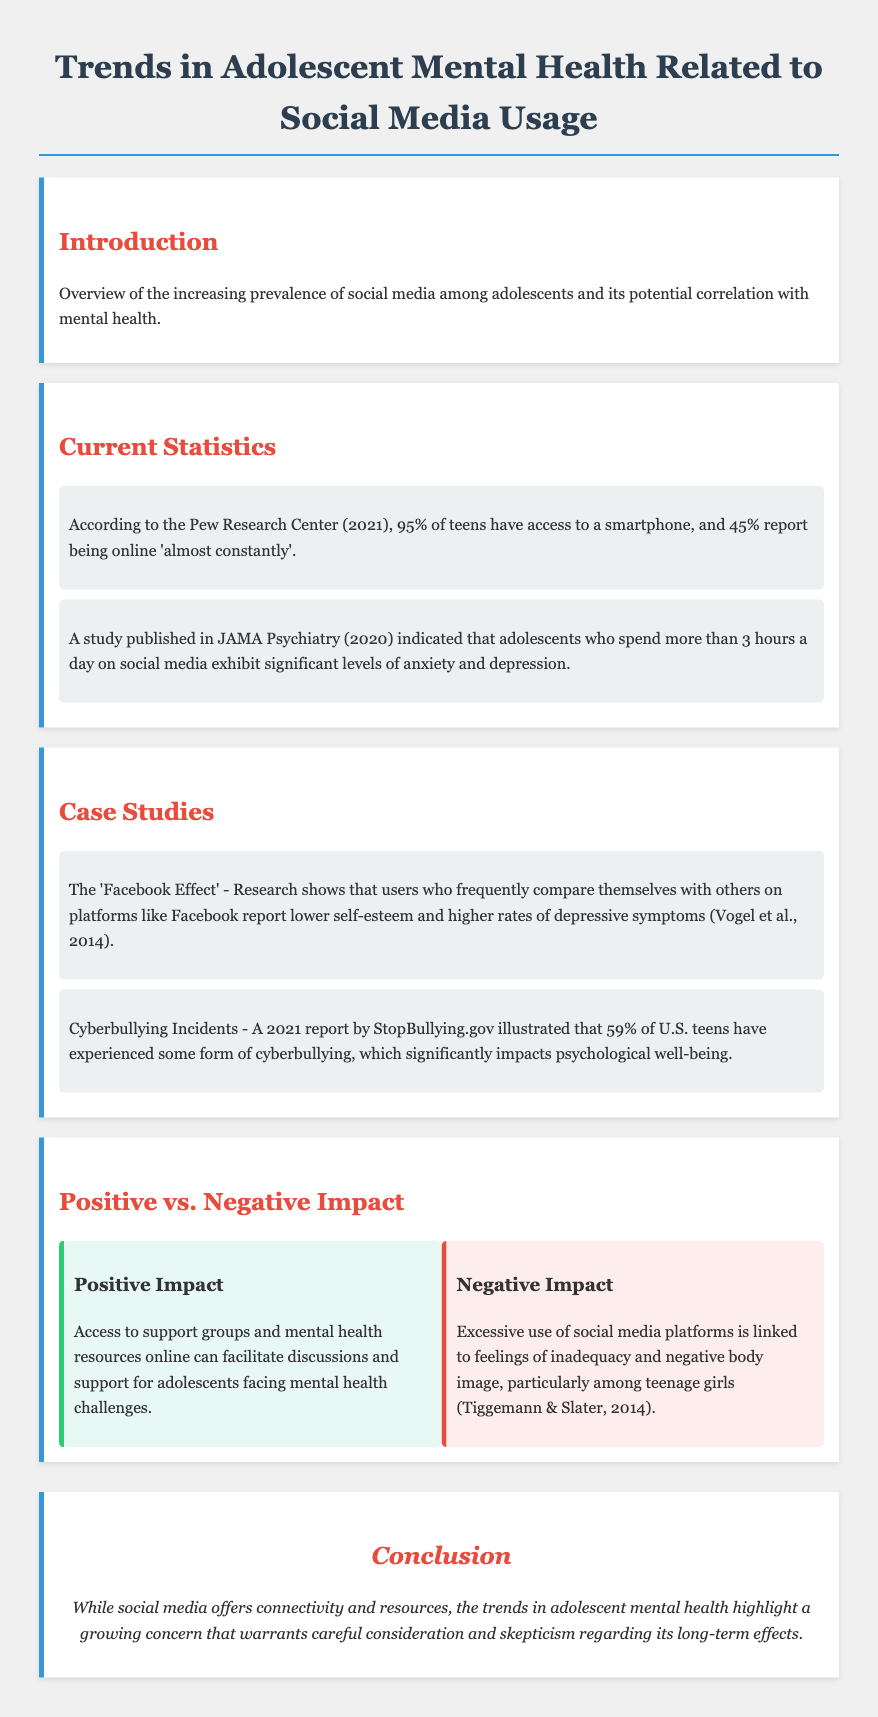What percentage of teens have access to a smartphone? The statistic states that 95% of teens have access to a smartphone.
Answer: 95% What is the significant threshold of daily social media use linked to anxiety and depression? The study indicates that spending more than 3 hours a day on social media is linked to significant anxiety and depression.
Answer: More than 3 hours What is the percentage of U.S. teens who have experienced cyberbullying? The report shows that 59% of U.S. teens have experienced cyberbullying.
Answer: 59% Which mental health issue is linked to comparing oneself on platforms like Facebook? The research mentions that users reporting lower self-esteem and higher rates of depressive symptoms are related to social comparison on Facebook.
Answer: Lower self-esteem What is one positive impact of social media for adolescents? The document states that access to support groups and mental health resources online can facilitate discussions for adolescents.
Answer: Access to support groups What is a negative impact of excessive social media use among teenage girls? The document mentions that excessive use is linked to feelings of inadequacy and negative body image.
Answer: Feelings of inadequacy What year did the Pew Research Center release their statistics on teen smartphone access? The document cites the Pew Research Center's statistics as being from the year 2021.
Answer: 2021 What does the conclusion suggest about the trends in adolescent mental health? The conclusion highlights a growing concern regarding the long-term effects of social media on adolescent mental health.
Answer: Growing concern 